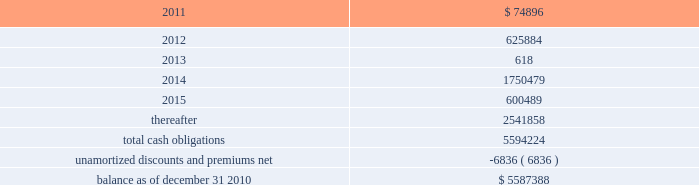American tower corporation and subsidiaries notes to consolidated financial statements as of december 31 , 2010 and 2009 , the company had $ 295.4 million and $ 295.0 million net , respectively ( $ 300.0 million aggregate principal amount ) outstanding under the 7.25% ( 7.25 % ) notes .
As of december 31 , 2010 and 2009 , the carrying value includes a discount of $ 4.6 million and $ 5.0 million , respectively .
5.0% ( 5.0 % ) convertible notes 2014the 5.0% ( 5.0 % ) convertible notes due 2010 ( 201c5.0% ( 201c5.0 % ) notes 201d ) matured on february 15 , 2010 , and interest was payable semiannually on february 15 and august 15 of each year .
The 5.0% ( 5.0 % ) notes were convertible at any time into shares of the company 2019s class a common stock ( 201ccommon stock 201d ) at a conversion price of $ 51.50 per share , subject to adjustment in certain cases .
As of december 31 , 2010 and 2009 , the company had none and $ 59.7 million outstanding , respectively , under the 5.0% ( 5.0 % ) notes .
Ati 7.25% ( 7.25 % ) senior subordinated notes 2014the ati 7.25% ( 7.25 % ) notes were issued with a maturity of december 1 , 2011 and interest was payable semi-annually in arrears on june 1 and december 1 of each year .
The ati 7.25% ( 7.25 % ) notes were jointly and severally guaranteed on a senior subordinated basis by the company and substantially all of the wholly owned domestic restricted subsidiaries of ati and the company , other than spectrasite and its subsidiaries .
The notes ranked junior in right of payment to all existing and future senior indebtedness of ati , the sister guarantors ( as defined in the indenture relating to the notes ) and their domestic restricted subsidiaries .
The ati 7.25% ( 7.25 % ) notes were structurally senior in right of payment to all other existing and future indebtedness of the company , including the company 2019s senior notes , convertible notes and the revolving credit facility and term loan .
During the year ended december 31 , 2010 , ati issued a notice for the redemption of the principal amount of its outstanding ati 7.25% ( 7.25 % ) notes .
In accordance with the redemption provisions and the indenture for the ati 7.25% ( 7.25 % ) notes , the notes were redeemed at a price equal to 100.00% ( 100.00 % ) of the principal amount , plus accrued and unpaid interest up to , but excluding , september 23 , 2010 , for an aggregate purchase price of $ 0.3 million .
As of december 31 , 2010 and 2009 , the company had none and $ 0.3 million , respectively , outstanding under the ati 7.25% ( 7.25 % ) notes .
Capital lease obligations and notes payable 2014the company 2019s capital lease obligations and notes payable approximated $ 46.3 million and $ 59.0 million as of december 31 , 2010 and 2009 , respectively .
These obligations bear interest at rates ranging from 2.5% ( 2.5 % ) to 9.3% ( 9.3 % ) and mature in periods ranging from less than one year to approximately seventy years .
Maturities 2014as of december 31 , 2010 , aggregate carrying value of long-term debt , including capital leases , for the next five years and thereafter are estimated to be ( in thousands ) : year ending december 31 .

As of december 31 , 2010 , what was the percent of the maturities of the aggregate carrying value of long-term debt due in 2012? 
Computations: (625884 / 5587388)
Answer: 0.11202. 